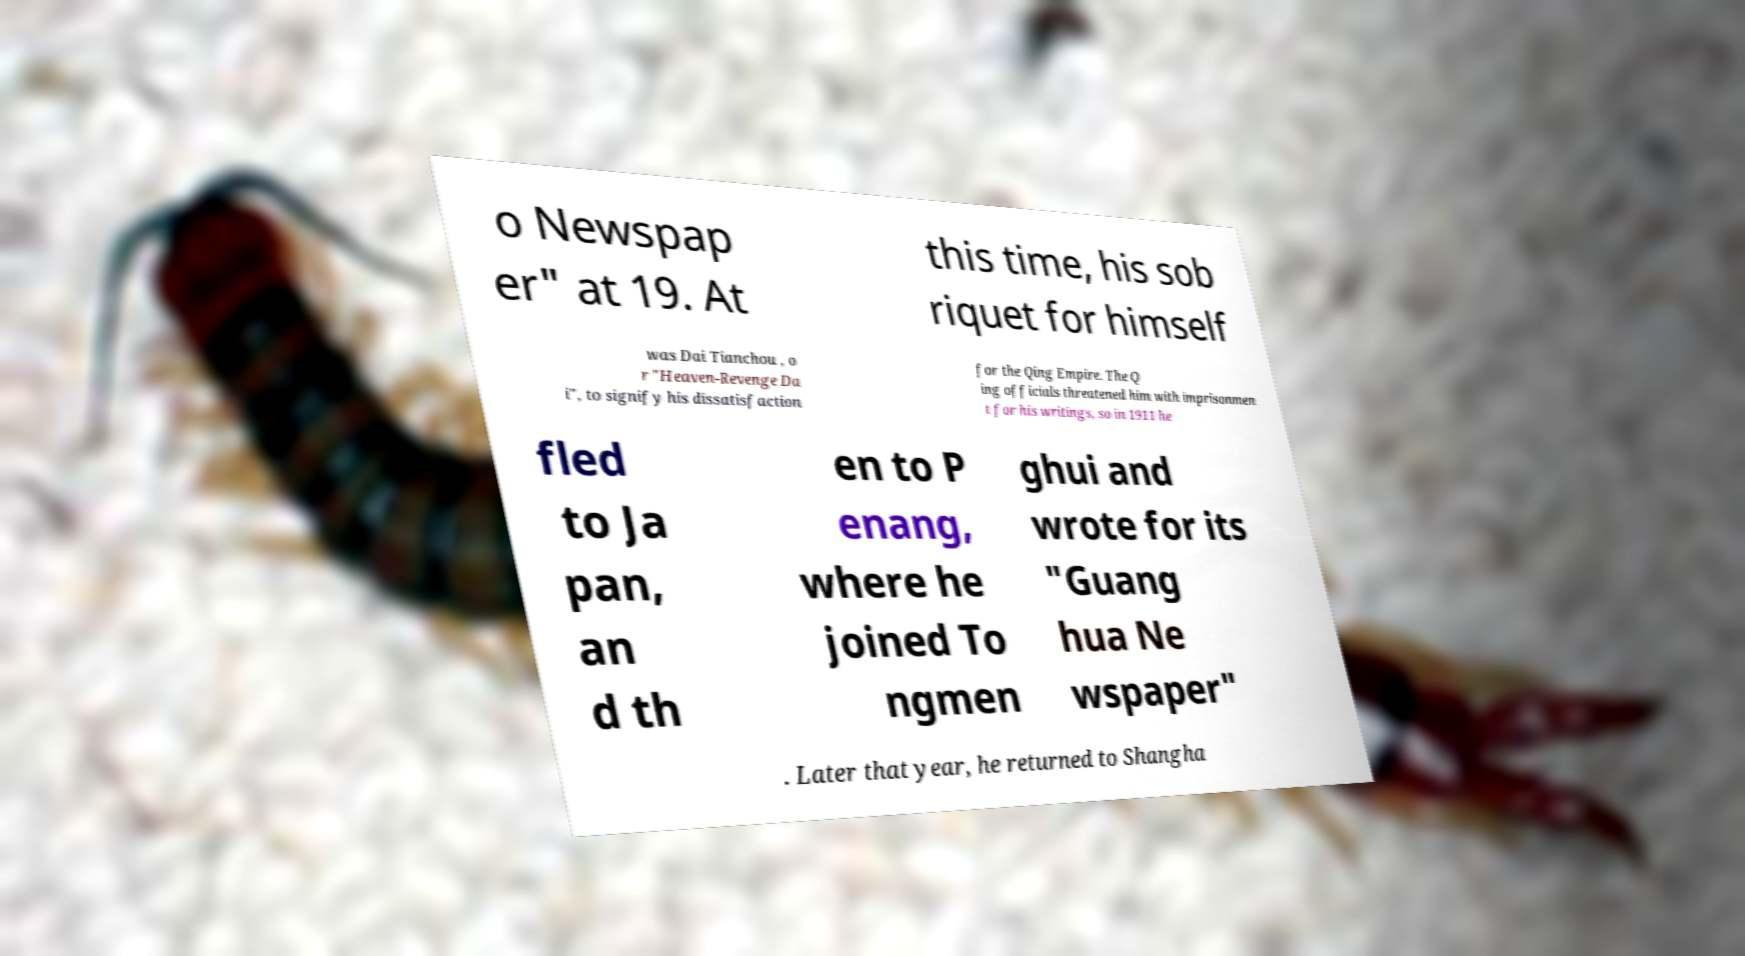Could you assist in decoding the text presented in this image and type it out clearly? o Newspap er" at 19. At this time, his sob riquet for himself was Dai Tianchou , o r "Heaven-Revenge Da i", to signify his dissatisfaction for the Qing Empire. The Q ing officials threatened him with imprisonmen t for his writings, so in 1911 he fled to Ja pan, an d th en to P enang, where he joined To ngmen ghui and wrote for its "Guang hua Ne wspaper" . Later that year, he returned to Shangha 